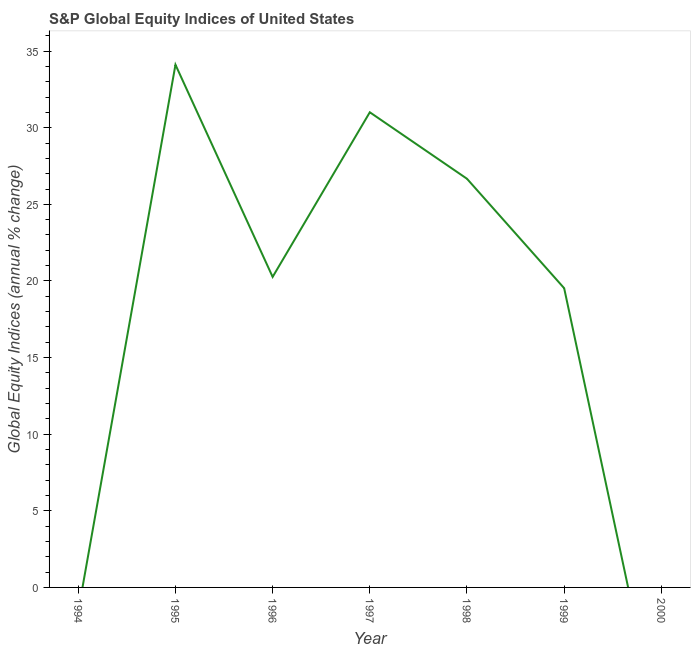What is the s&p global equity indices in 1996?
Offer a terse response. 20.26. Across all years, what is the maximum s&p global equity indices?
Offer a terse response. 34.11. Across all years, what is the minimum s&p global equity indices?
Make the answer very short. 0. What is the sum of the s&p global equity indices?
Provide a short and direct response. 131.58. What is the difference between the s&p global equity indices in 1996 and 1999?
Ensure brevity in your answer.  0.74. What is the average s&p global equity indices per year?
Keep it short and to the point. 18.8. What is the median s&p global equity indices?
Provide a short and direct response. 20.26. In how many years, is the s&p global equity indices greater than 17 %?
Ensure brevity in your answer.  5. What is the ratio of the s&p global equity indices in 1997 to that in 1999?
Make the answer very short. 1.59. What is the difference between the highest and the second highest s&p global equity indices?
Make the answer very short. 3.1. Is the sum of the s&p global equity indices in 1996 and 1998 greater than the maximum s&p global equity indices across all years?
Give a very brief answer. Yes. What is the difference between the highest and the lowest s&p global equity indices?
Keep it short and to the point. 34.11. In how many years, is the s&p global equity indices greater than the average s&p global equity indices taken over all years?
Offer a terse response. 5. Does the s&p global equity indices monotonically increase over the years?
Your answer should be compact. No. How many years are there in the graph?
Provide a succinct answer. 7. Are the values on the major ticks of Y-axis written in scientific E-notation?
Give a very brief answer. No. Does the graph contain grids?
Provide a succinct answer. No. What is the title of the graph?
Your answer should be very brief. S&P Global Equity Indices of United States. What is the label or title of the Y-axis?
Your response must be concise. Global Equity Indices (annual % change). What is the Global Equity Indices (annual % change) in 1995?
Give a very brief answer. 34.11. What is the Global Equity Indices (annual % change) of 1996?
Provide a succinct answer. 20.26. What is the Global Equity Indices (annual % change) in 1997?
Your response must be concise. 31.01. What is the Global Equity Indices (annual % change) of 1998?
Your answer should be compact. 26.67. What is the Global Equity Indices (annual % change) in 1999?
Your answer should be compact. 19.53. What is the difference between the Global Equity Indices (annual % change) in 1995 and 1996?
Provide a short and direct response. 13.85. What is the difference between the Global Equity Indices (annual % change) in 1995 and 1997?
Your answer should be compact. 3.1. What is the difference between the Global Equity Indices (annual % change) in 1995 and 1998?
Offer a terse response. 7.44. What is the difference between the Global Equity Indices (annual % change) in 1995 and 1999?
Ensure brevity in your answer.  14.58. What is the difference between the Global Equity Indices (annual % change) in 1996 and 1997?
Provide a succinct answer. -10.74. What is the difference between the Global Equity Indices (annual % change) in 1996 and 1998?
Offer a very short reply. -6.4. What is the difference between the Global Equity Indices (annual % change) in 1996 and 1999?
Your answer should be compact. 0.74. What is the difference between the Global Equity Indices (annual % change) in 1997 and 1998?
Provide a short and direct response. 4.34. What is the difference between the Global Equity Indices (annual % change) in 1997 and 1999?
Offer a very short reply. 11.48. What is the difference between the Global Equity Indices (annual % change) in 1998 and 1999?
Your answer should be very brief. 7.14. What is the ratio of the Global Equity Indices (annual % change) in 1995 to that in 1996?
Make the answer very short. 1.68. What is the ratio of the Global Equity Indices (annual % change) in 1995 to that in 1997?
Your answer should be very brief. 1.1. What is the ratio of the Global Equity Indices (annual % change) in 1995 to that in 1998?
Provide a short and direct response. 1.28. What is the ratio of the Global Equity Indices (annual % change) in 1995 to that in 1999?
Provide a succinct answer. 1.75. What is the ratio of the Global Equity Indices (annual % change) in 1996 to that in 1997?
Your answer should be compact. 0.65. What is the ratio of the Global Equity Indices (annual % change) in 1996 to that in 1998?
Provide a succinct answer. 0.76. What is the ratio of the Global Equity Indices (annual % change) in 1996 to that in 1999?
Ensure brevity in your answer.  1.04. What is the ratio of the Global Equity Indices (annual % change) in 1997 to that in 1998?
Your answer should be very brief. 1.16. What is the ratio of the Global Equity Indices (annual % change) in 1997 to that in 1999?
Your answer should be very brief. 1.59. What is the ratio of the Global Equity Indices (annual % change) in 1998 to that in 1999?
Offer a terse response. 1.37. 